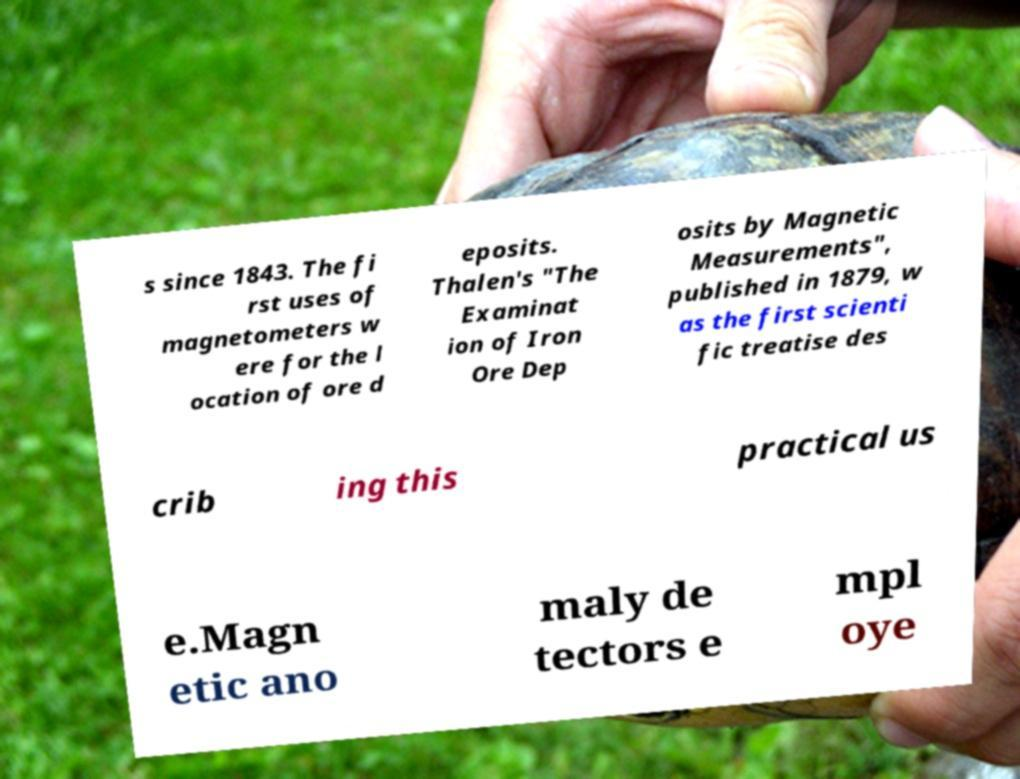Please identify and transcribe the text found in this image. s since 1843. The fi rst uses of magnetometers w ere for the l ocation of ore d eposits. Thalen's "The Examinat ion of Iron Ore Dep osits by Magnetic Measurements", published in 1879, w as the first scienti fic treatise des crib ing this practical us e.Magn etic ano maly de tectors e mpl oye 